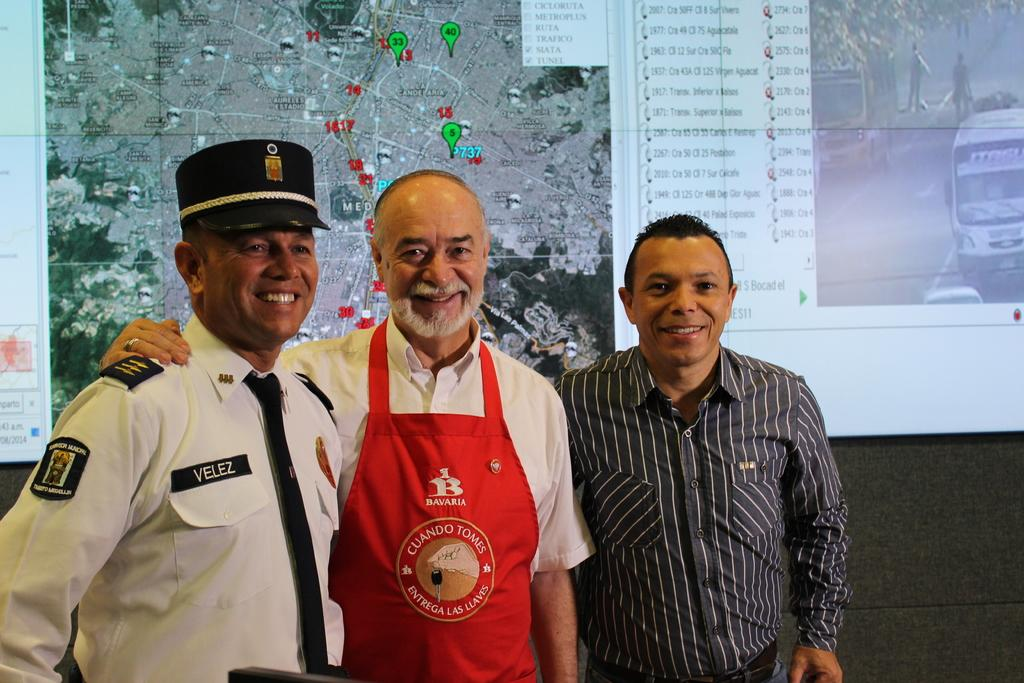<image>
Summarize the visual content of the image. Three men pose with one man wearing a red apron that says Bavaria. 